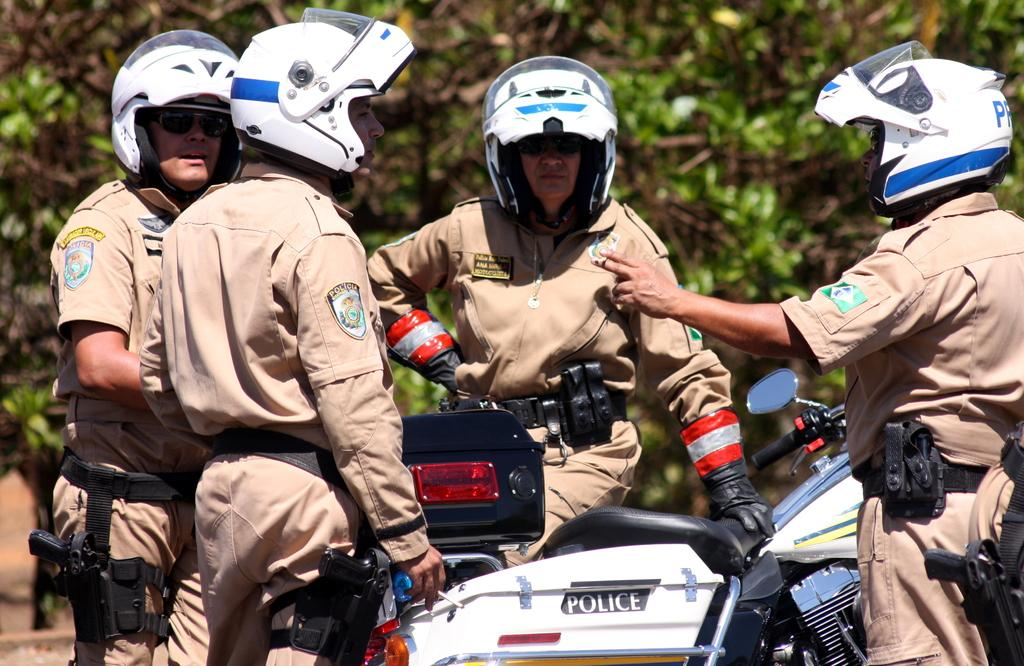Who or what is present in the image? There are people in the image. What are the people wearing on their heads? The people are wearing helmets. What are the people holding in their hands? The people are holding guns. What can be seen in the middle of the image? There is a bike in the middle of the image. What type of natural scenery is visible in the background? There are trees in the background of the image. What type of trousers are the people wearing in the image? There is no information about the type of trousers the people are wearing in the image. How many cabbages can be seen in the image? There are no cabbages present in the image. 